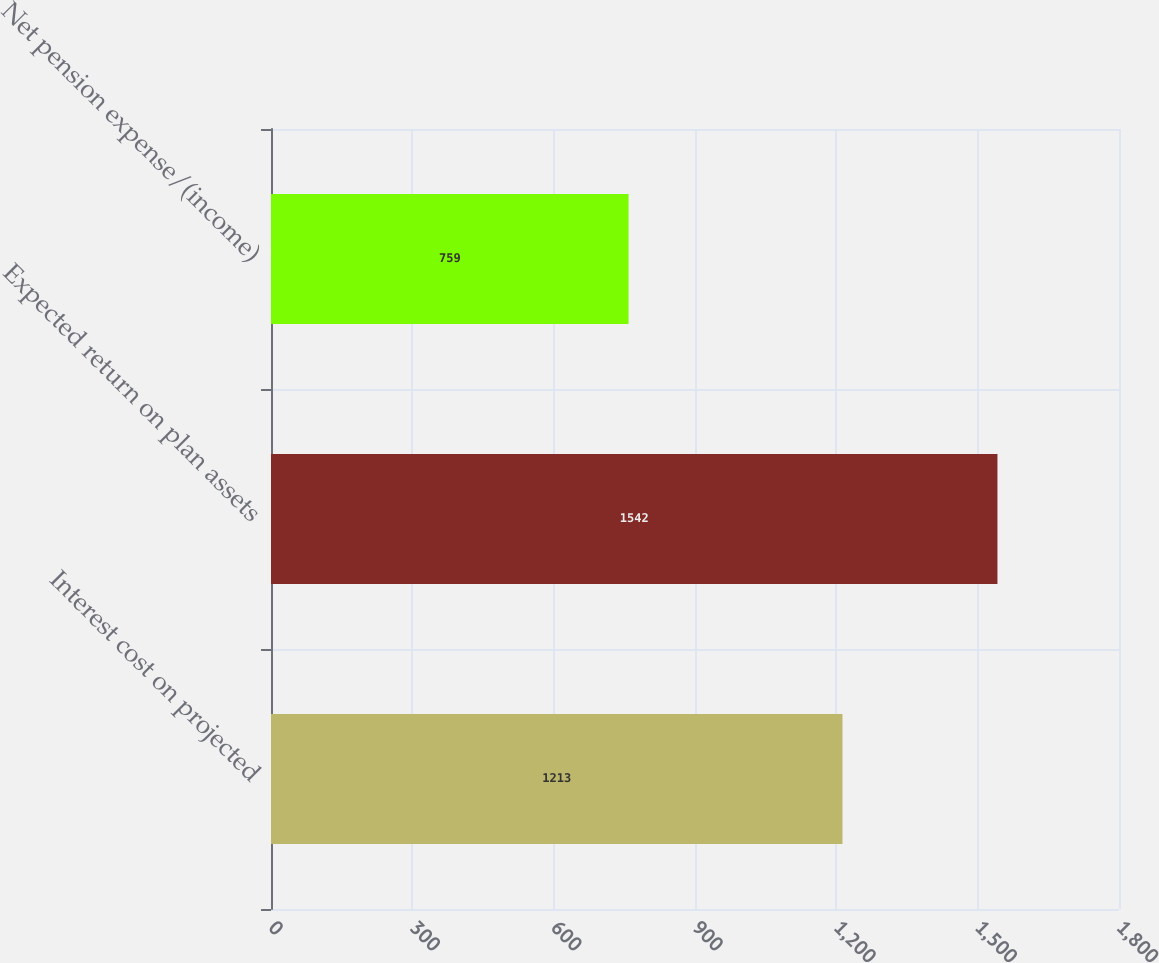<chart> <loc_0><loc_0><loc_500><loc_500><bar_chart><fcel>Interest cost on projected<fcel>Expected return on plan assets<fcel>Net pension expense/(income)<nl><fcel>1213<fcel>1542<fcel>759<nl></chart> 